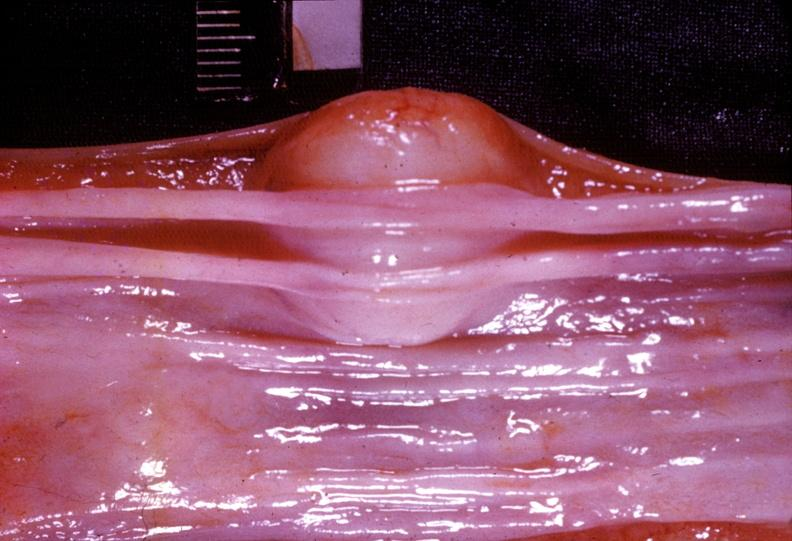s gastrointestinal present?
Answer the question using a single word or phrase. Yes 